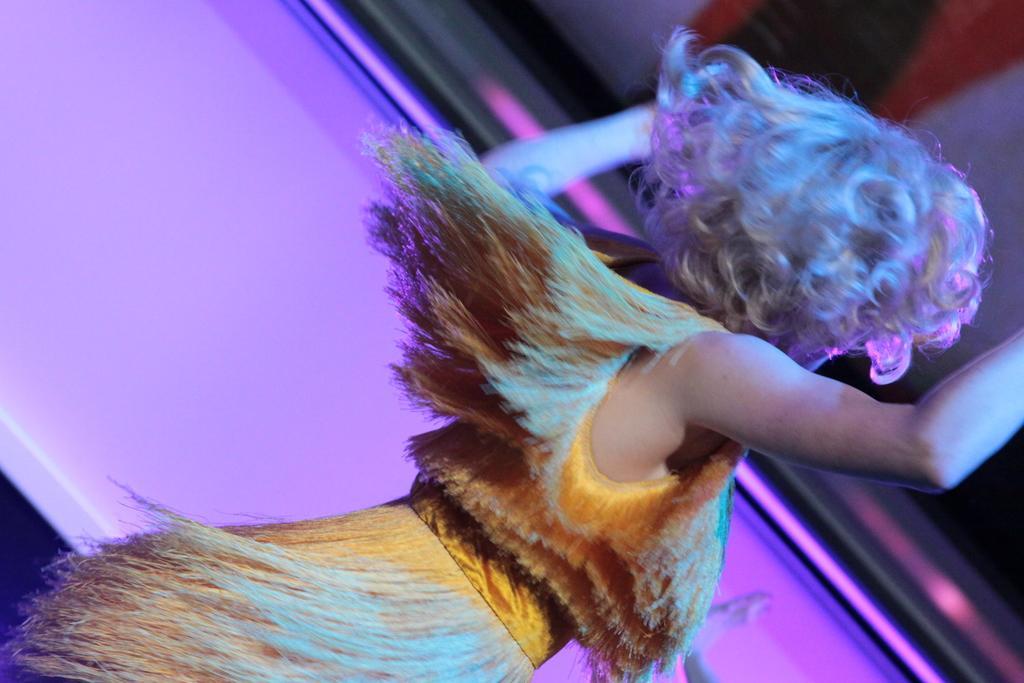Please provide a concise description of this image. In this image we can see a woman dancing, and some part of the background is pink in color. 